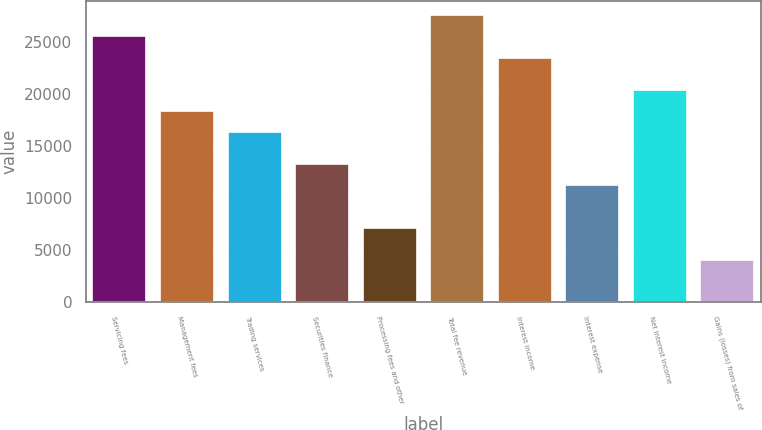Convert chart to OTSL. <chart><loc_0><loc_0><loc_500><loc_500><bar_chart><fcel>Servicing fees<fcel>Management fees<fcel>Trading services<fcel>Securities finance<fcel>Processing fees and other<fcel>Total fee revenue<fcel>Interest income<fcel>Interest expense<fcel>Net interest income<fcel>Gains (losses) from sales of<nl><fcel>25515.4<fcel>18371.5<fcel>16330.4<fcel>13268.7<fcel>7145.36<fcel>27556.6<fcel>23474.3<fcel>11227.6<fcel>20412.6<fcel>4083.68<nl></chart> 